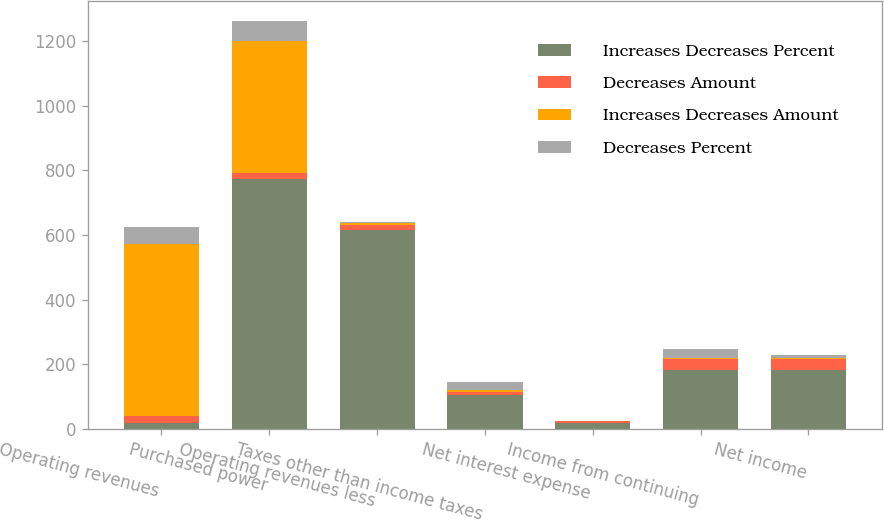<chart> <loc_0><loc_0><loc_500><loc_500><stacked_bar_chart><ecel><fcel>Operating revenues<fcel>Purchased power<fcel>Operating revenues less<fcel>Taxes other than income taxes<fcel>Net interest expense<fcel>Income from continuing<fcel>Net income<nl><fcel>Increases Decreases Percent<fcel>20<fcel>773<fcel>616<fcel>105<fcel>20<fcel>183<fcel>182<nl><fcel>Decreases Amount<fcel>19.6<fcel>19.7<fcel>14.1<fcel>9.7<fcel>4.5<fcel>33.3<fcel>33.9<nl><fcel>Increases Decreases Amount<fcel>534<fcel>406<fcel>7<fcel>5<fcel>1<fcel>4<fcel>3<nl><fcel>Decreases Percent<fcel>50.6<fcel>62.5<fcel>3.7<fcel>26.3<fcel>1.3<fcel>26.7<fcel>11.1<nl></chart> 